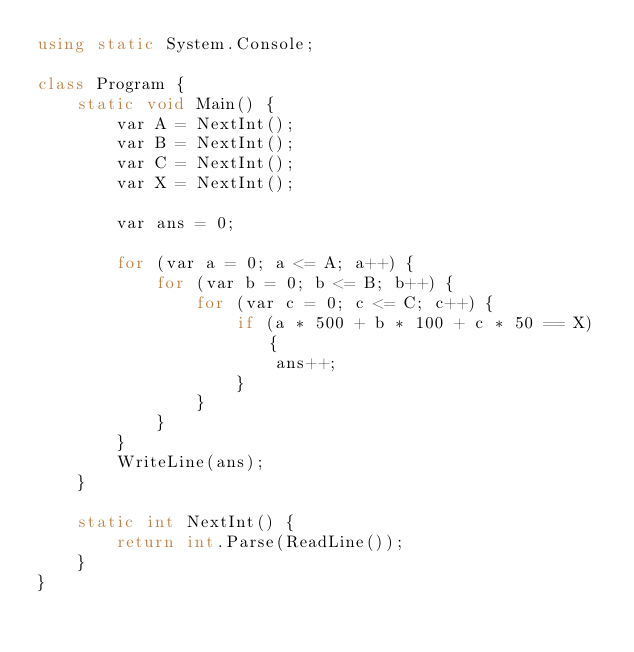<code> <loc_0><loc_0><loc_500><loc_500><_C#_>using static System.Console;

class Program {
	static void Main() {
		var A = NextInt();
		var B = NextInt();
		var C = NextInt();
		var X = NextInt();

		var ans = 0;

		for (var a = 0; a <= A; a++) {
			for (var b = 0; b <= B; b++) {
				for (var c = 0; c <= C; c++) {
					if (a * 500 + b * 100 + c * 50 == X) {
						ans++;
					}
				}
			}
		}
		WriteLine(ans);
	}

	static int NextInt() {
		return int.Parse(ReadLine());
	}
}</code> 